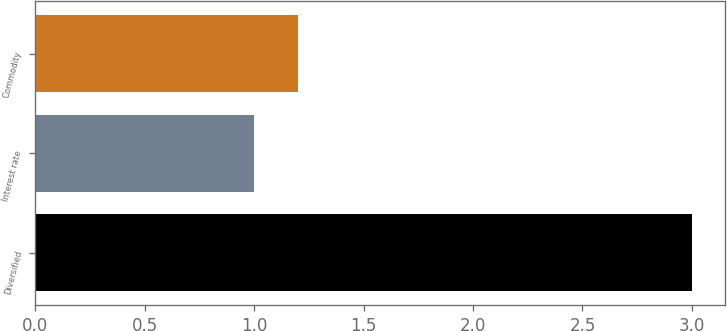Convert chart to OTSL. <chart><loc_0><loc_0><loc_500><loc_500><bar_chart><fcel>Diversified<fcel>Interest rate<fcel>Commodity<nl><fcel>3<fcel>1<fcel>1.2<nl></chart> 